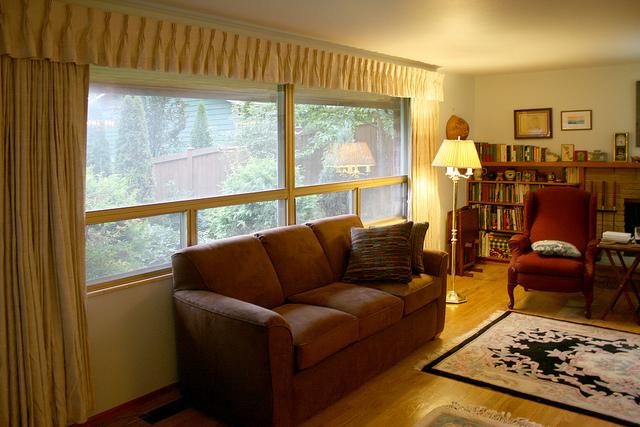Is the lamp on or off?
Give a very brief answer. On. Are trees visible from the windows?
Write a very short answer. Yes. Where are the pillows?
Be succinct. Couch. Are the curtains open or shut?
Give a very brief answer. Open. What type of room is this?
Give a very brief answer. Living room. What room could this be?
Be succinct. Living room. Is this a house or an apartment?
Be succinct. House. Is the photo clear?
Answer briefly. Yes. 